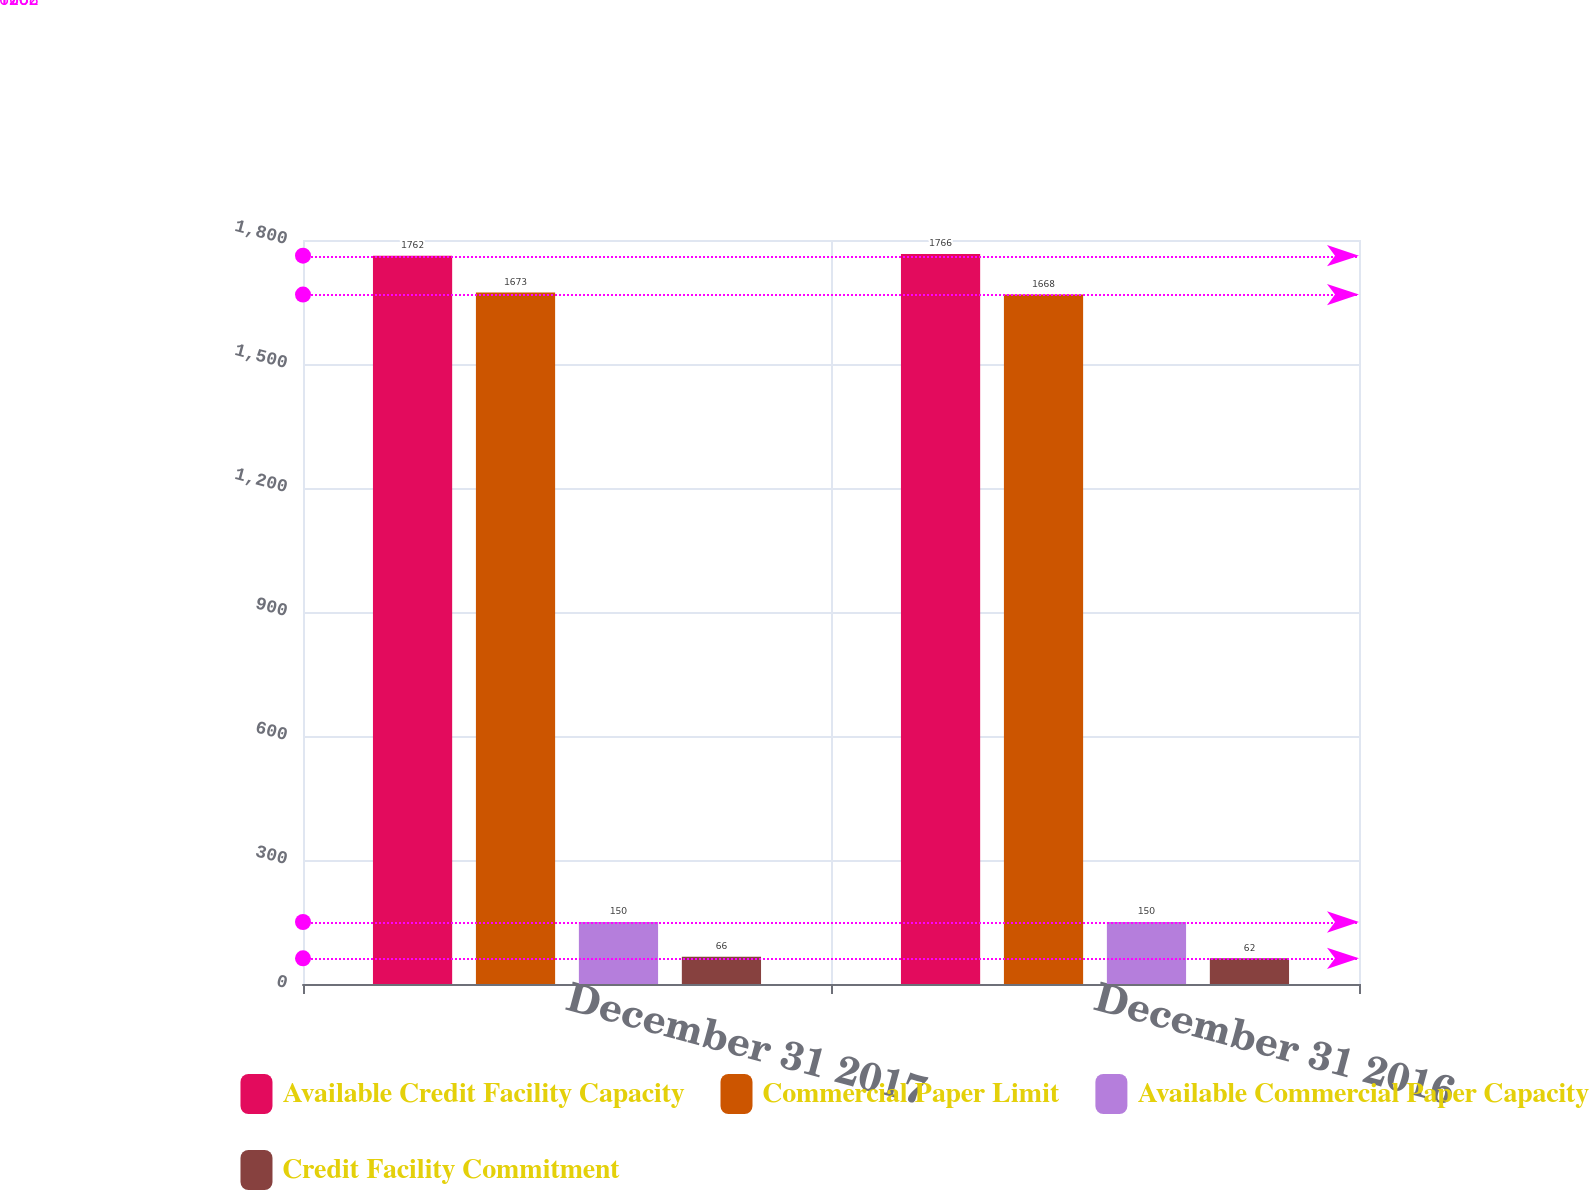Convert chart. <chart><loc_0><loc_0><loc_500><loc_500><stacked_bar_chart><ecel><fcel>December 31 2017<fcel>December 31 2016<nl><fcel>Available Credit Facility Capacity<fcel>1762<fcel>1766<nl><fcel>Commercial Paper Limit<fcel>1673<fcel>1668<nl><fcel>Available Commercial Paper Capacity<fcel>150<fcel>150<nl><fcel>Credit Facility Commitment<fcel>66<fcel>62<nl></chart> 